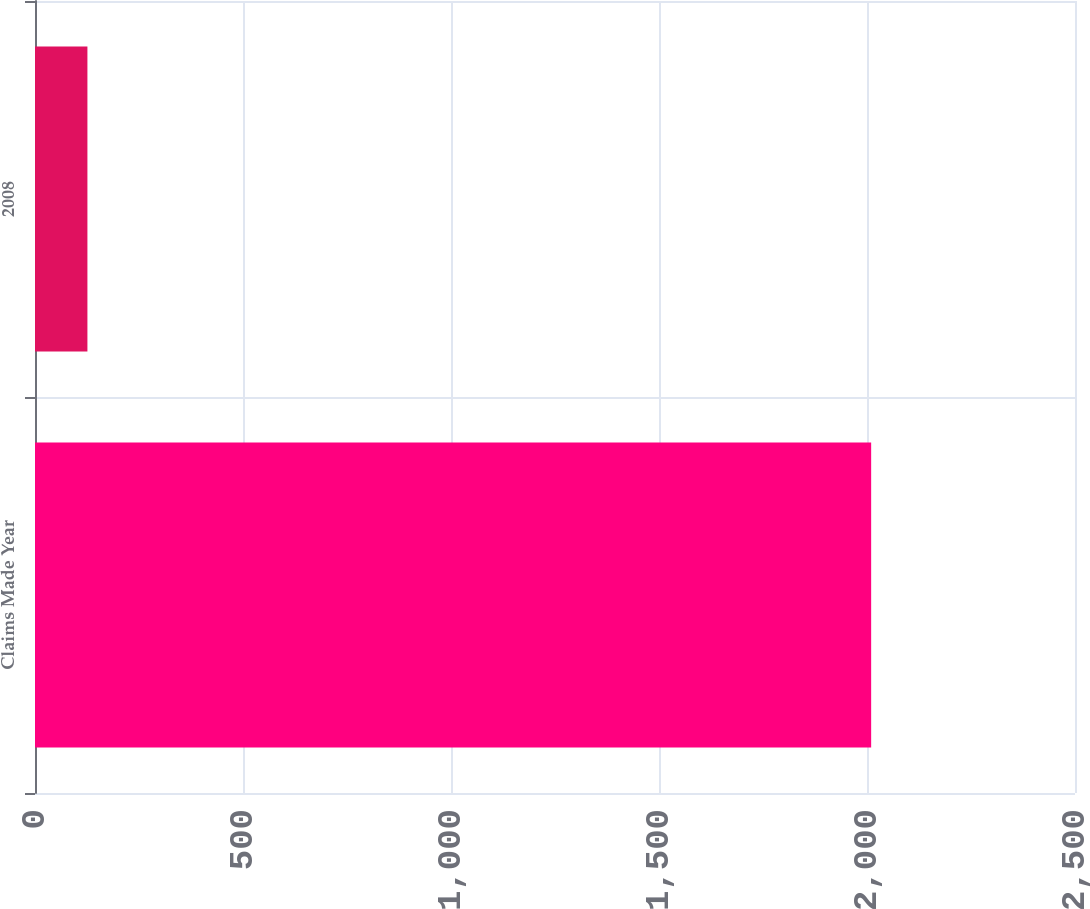Convert chart to OTSL. <chart><loc_0><loc_0><loc_500><loc_500><bar_chart><fcel>Claims Made Year<fcel>2008<nl><fcel>2010<fcel>126<nl></chart> 